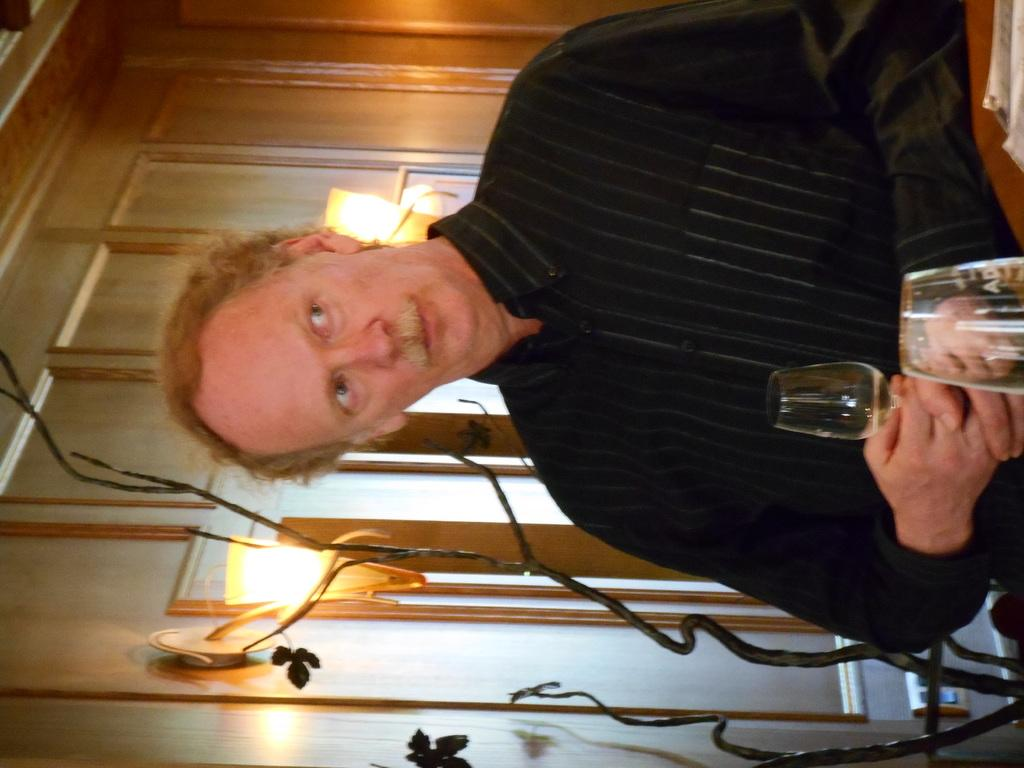What is the man in the image wearing? The man in the image is wearing a black shirt. What is the man doing in the image? The man is staring. What object is the man holding in the image? The man is holding a glass. What can be seen on the wall in the image? There are lights on the wall in the image. What theory is the man discussing in the image? There is no indication in the image that the man is discussing a theory. 